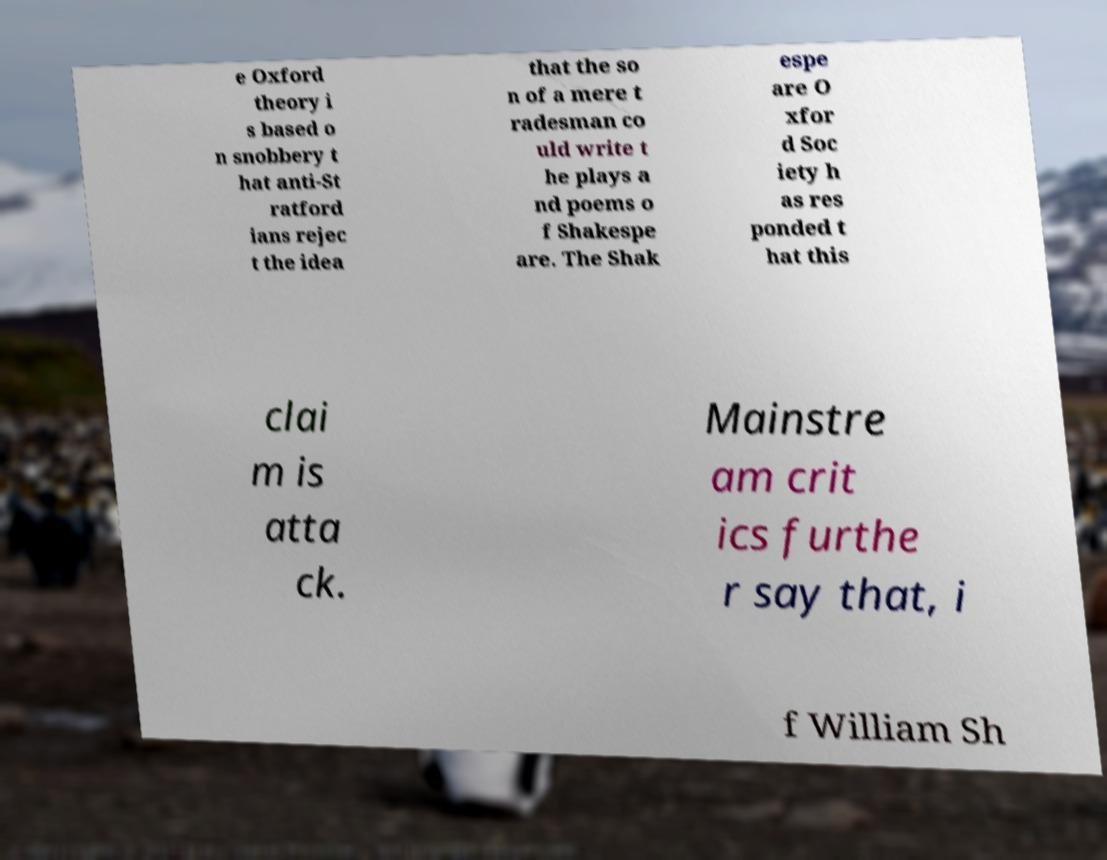Could you extract and type out the text from this image? e Oxford theory i s based o n snobbery t hat anti-St ratford ians rejec t the idea that the so n of a mere t radesman co uld write t he plays a nd poems o f Shakespe are. The Shak espe are O xfor d Soc iety h as res ponded t hat this clai m is atta ck. Mainstre am crit ics furthe r say that, i f William Sh 